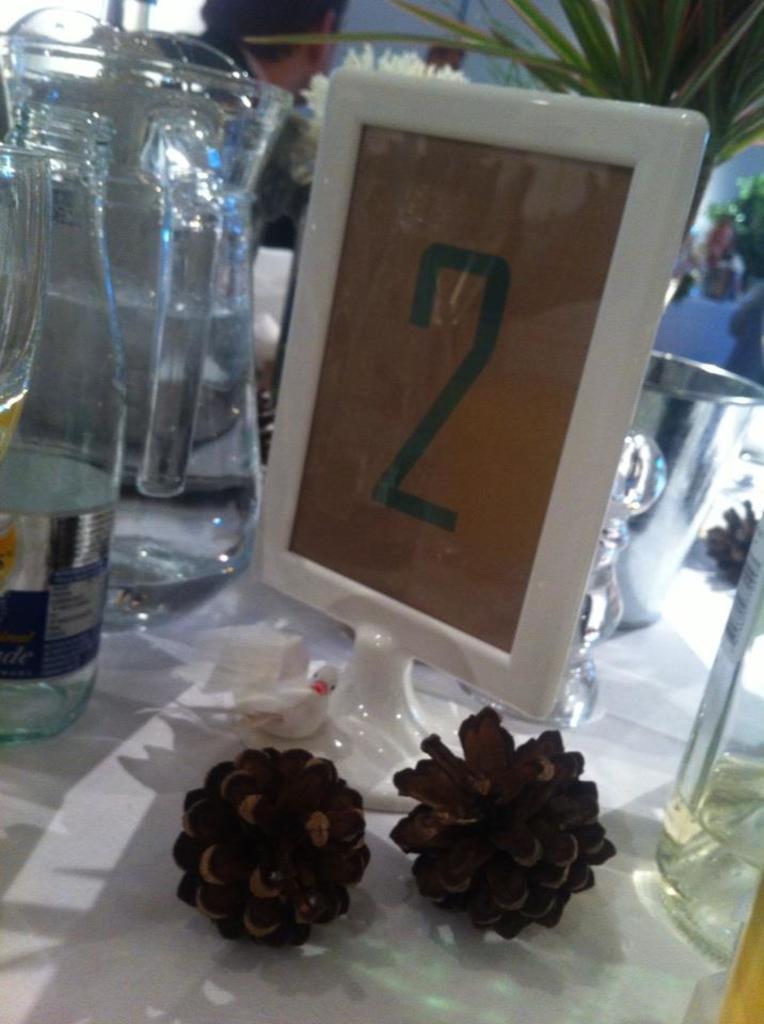Describe this image in one or two sentences. In the image we can see there is a jug and a bottle and on a tile i can see a number which is "2" and in front there are two flowers. 